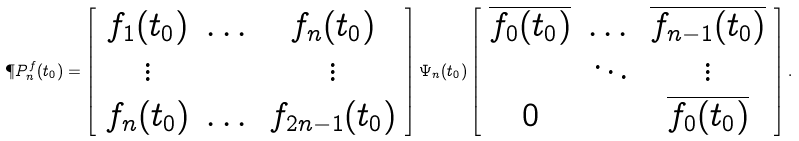Convert formula to latex. <formula><loc_0><loc_0><loc_500><loc_500>\P P ^ { f } _ { n } ( t _ { 0 } ) = \left [ \begin{array} { c c c } f _ { 1 } ( t _ { 0 } ) & \dots & f _ { n } ( t _ { 0 } ) \\ \vdots & & \vdots \\ f _ { n } ( t _ { 0 } ) & \dots & f _ { 2 n - 1 } ( t _ { 0 } ) \end{array} \right ] { \Psi } _ { n } ( t _ { 0 } ) \left [ \begin{array} { c c c } \overline { f _ { 0 } ( t _ { 0 } ) } & \dots & \overline { f _ { n - 1 } ( t _ { 0 } ) } \\ & \ddots & \vdots \\ 0 & & \overline { f _ { 0 } ( t _ { 0 } ) } \end{array} \right ] .</formula> 